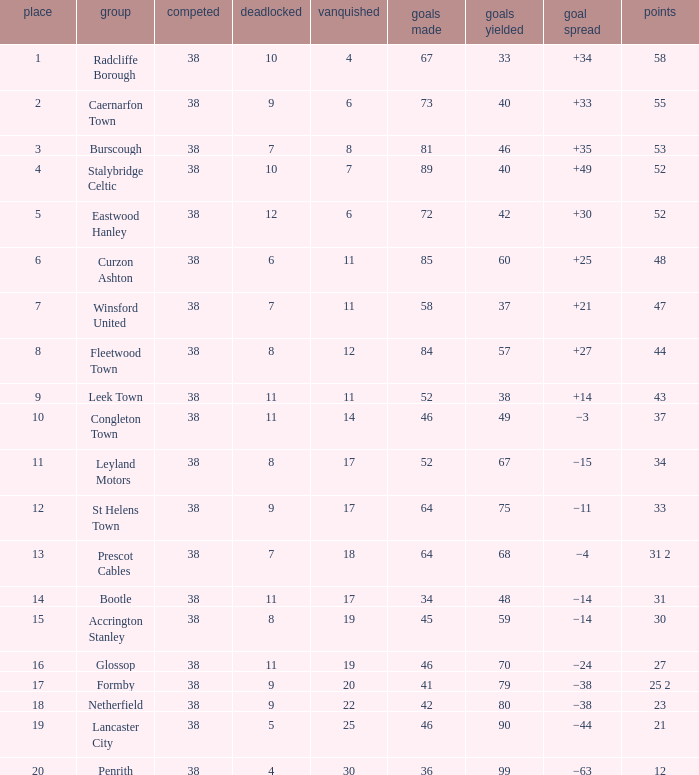WHAT POINTS 1 HAD A 22 LOST? 23.0. 